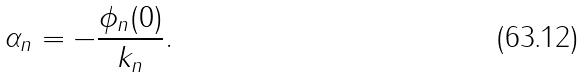Convert formula to latex. <formula><loc_0><loc_0><loc_500><loc_500>\alpha _ { n } = - \frac { \phi _ { n } ( 0 ) } { k _ { n } } .</formula> 